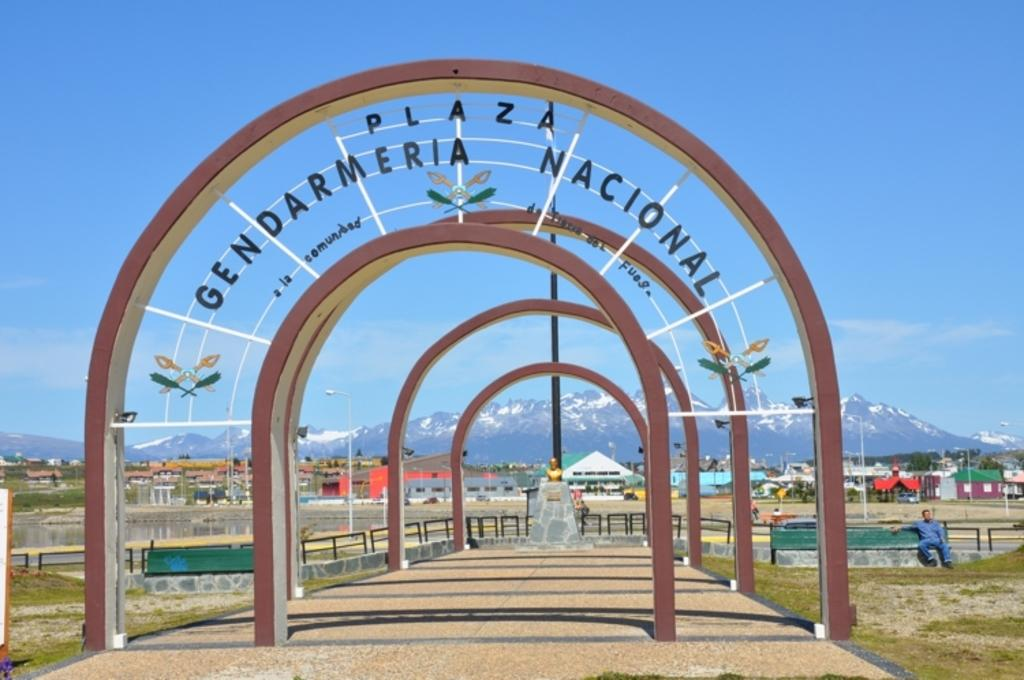What architectural feature can be seen in the image? There are arches in the image. What is written on the arches? Something is written on the arches. What can be seen in the background of the image? There is a statue, light poles, mountains, tents, a fence, benches, and a person in the background of the image. What is the color of the sky in the image? The sky is blue in color. What type of canvas is the tiger painting in the image? There is no canvas or tiger present in the image. How many people are visible in the image? There is only one person visible in the image, as mentioned in the facts. 